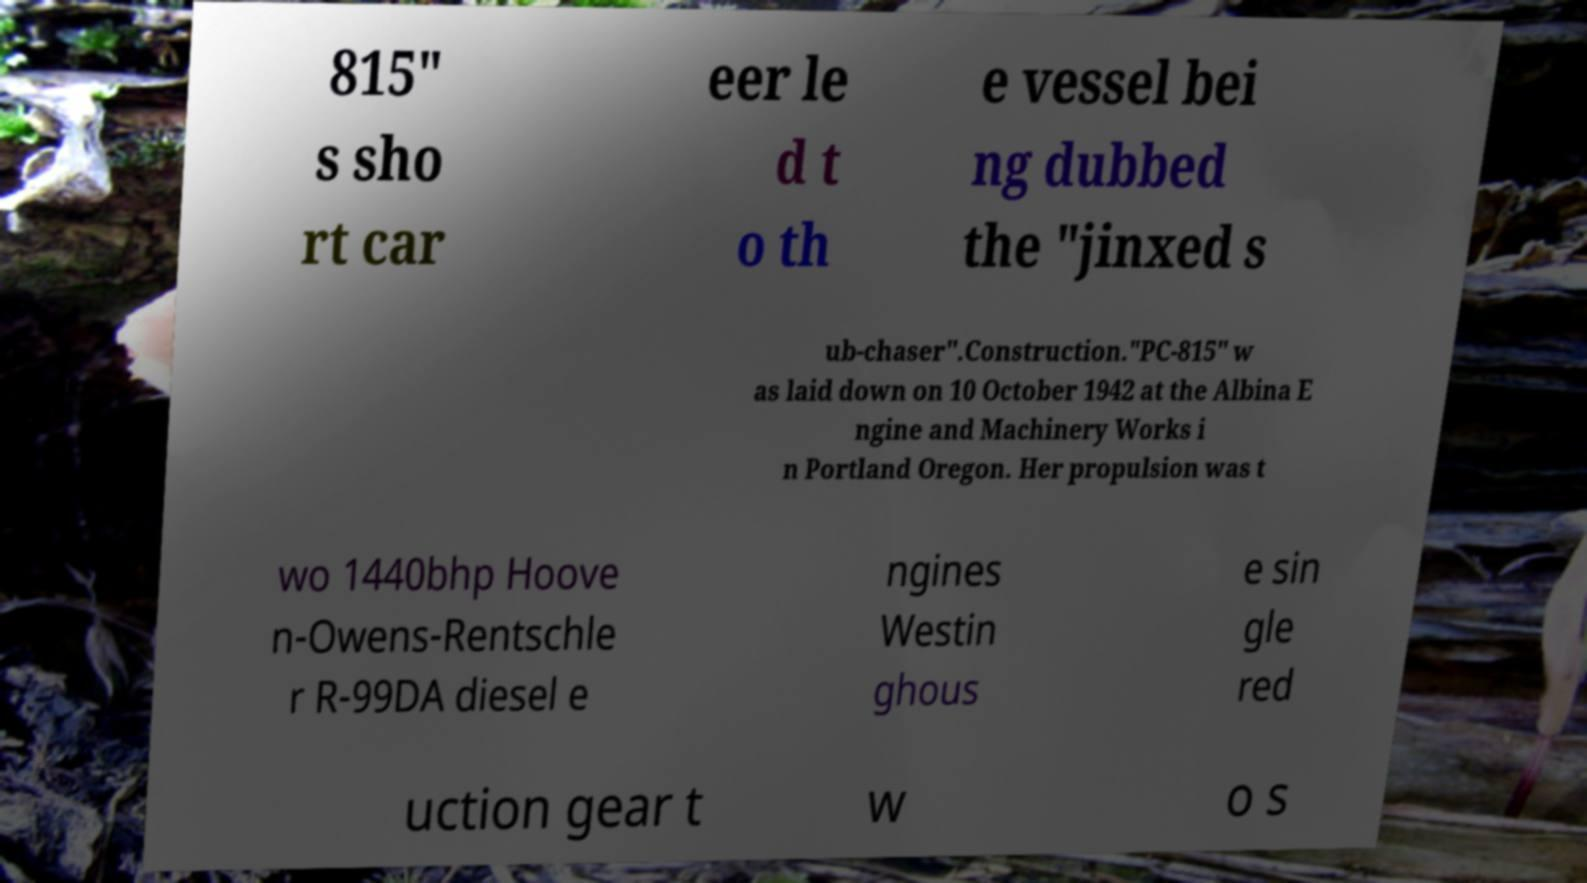Can you read and provide the text displayed in the image?This photo seems to have some interesting text. Can you extract and type it out for me? 815" s sho rt car eer le d t o th e vessel bei ng dubbed the "jinxed s ub-chaser".Construction."PC-815" w as laid down on 10 October 1942 at the Albina E ngine and Machinery Works i n Portland Oregon. Her propulsion was t wo 1440bhp Hoove n-Owens-Rentschle r R-99DA diesel e ngines Westin ghous e sin gle red uction gear t w o s 